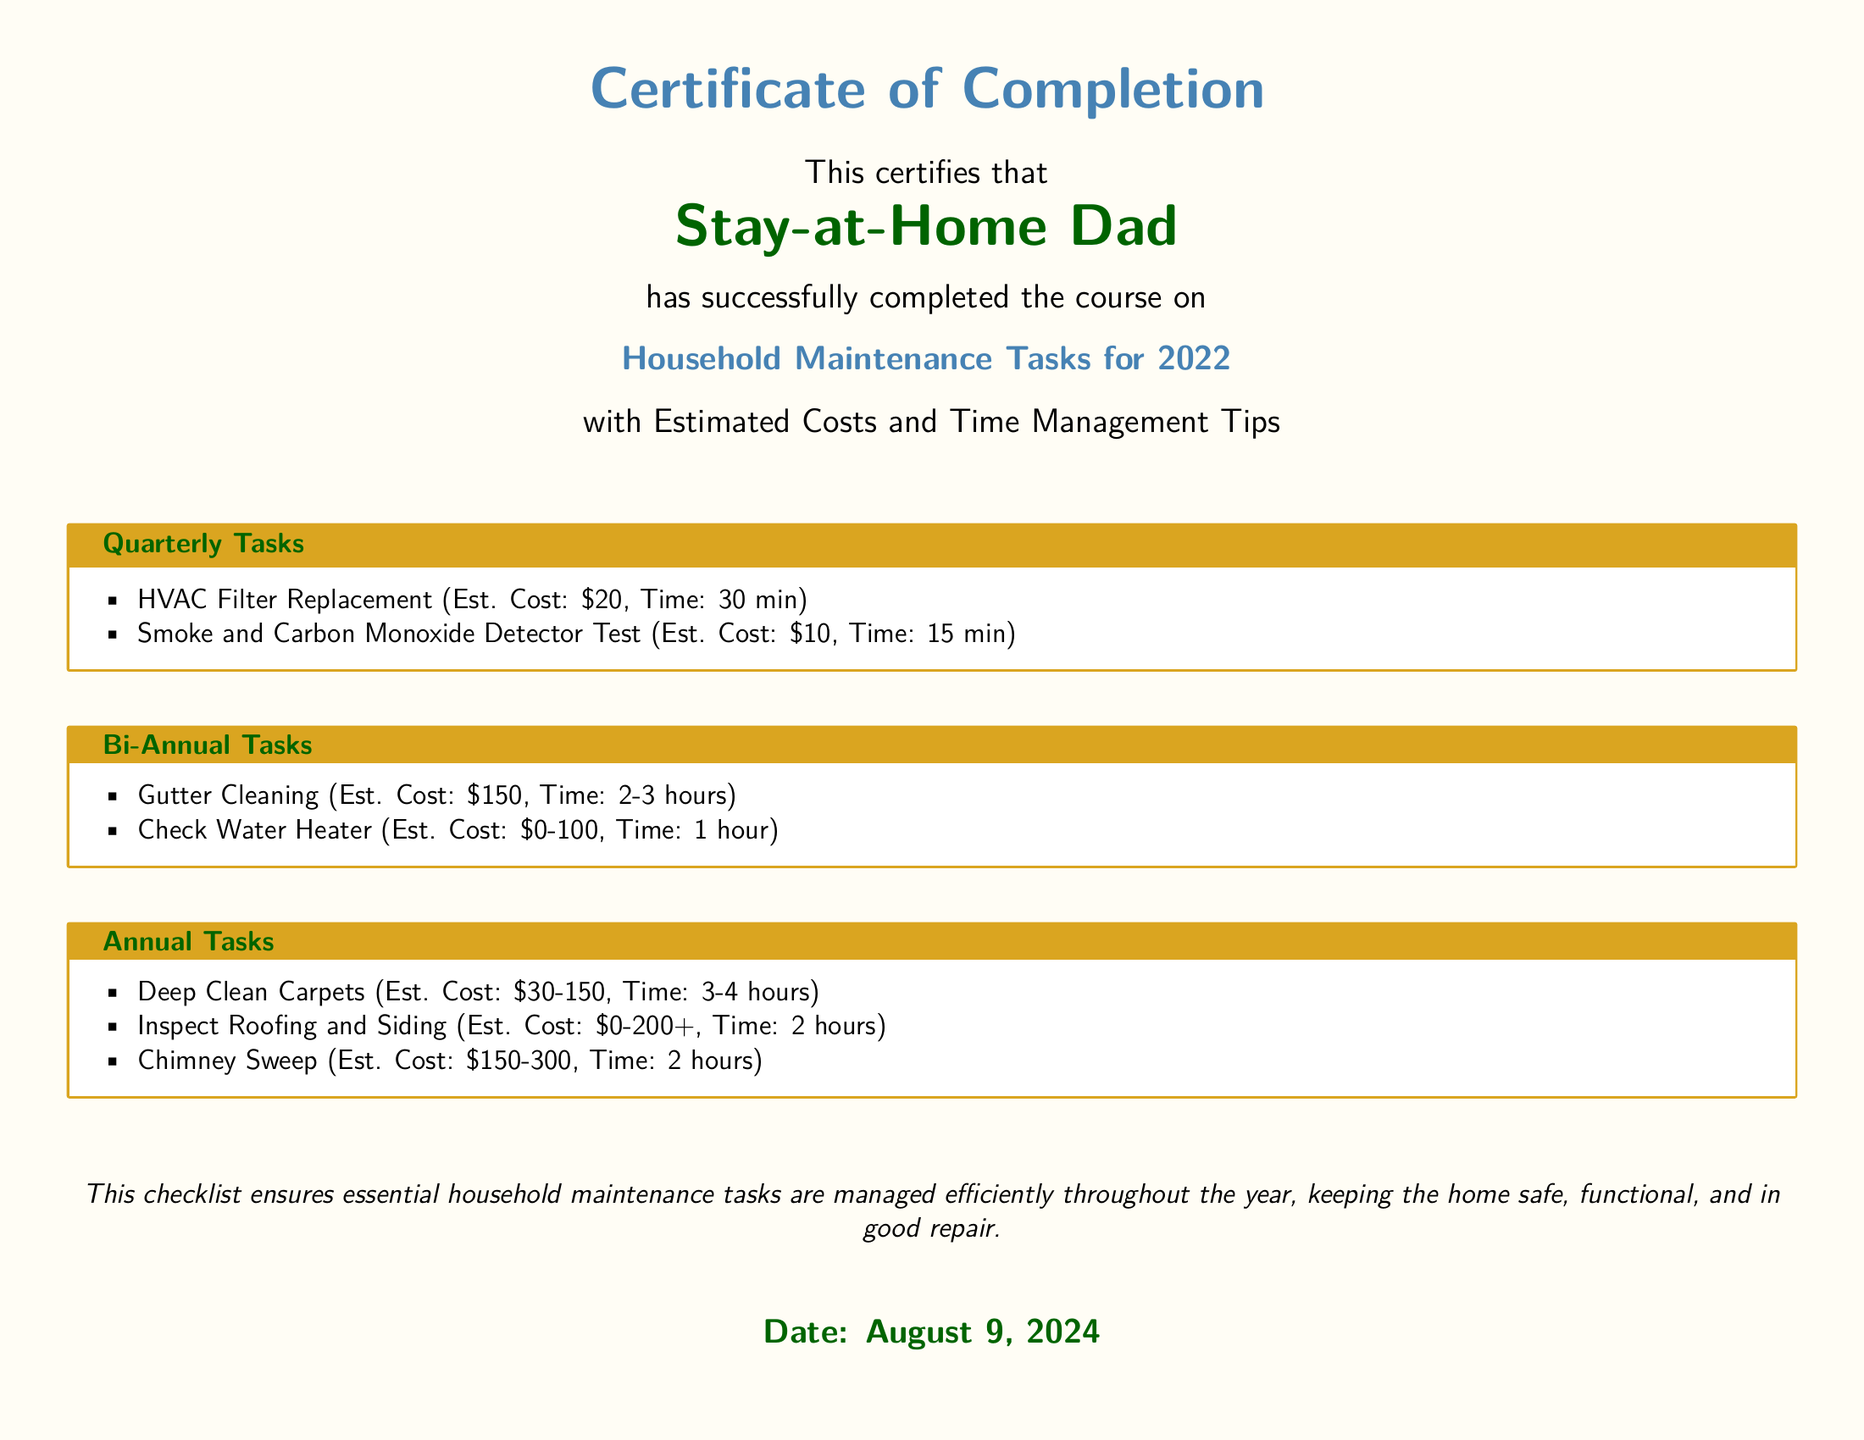What is the title of the diploma? The title of the diploma is presented prominently at the top of the document.
Answer: Household Maintenance Tasks for 2022 Who completed the course? The document mentions the individual who has completed the course in a specific section.
Answer: Stay-at-Home Dad What is the estimated cost for HVAC Filter Replacement? The estimated cost for this task is clearly listed in the quarterly tasks section.
Answer: $20 How much time is needed for Gutter Cleaning? The required time for this task can be found in the bi-annual tasks list.
Answer: 2-3 hours What is the estimated cost range for Deep Clean Carpets? The cost range for this annual task is mentioned in the respective section of the document.
Answer: $30-150 Which task requires testing of detectors? This task is specifically mentioned in the quarterly section of the document.
Answer: Smoke and Carbon Monoxide Detector Test What is the main purpose of the checklist? The document includes a statement about the intention behind the checklist at the bottom.
Answer: Manage essential household maintenance tasks How often should you check the water heater? The frequency of this task is indicated under a specific category in the document.
Answer: Bi-Annual 